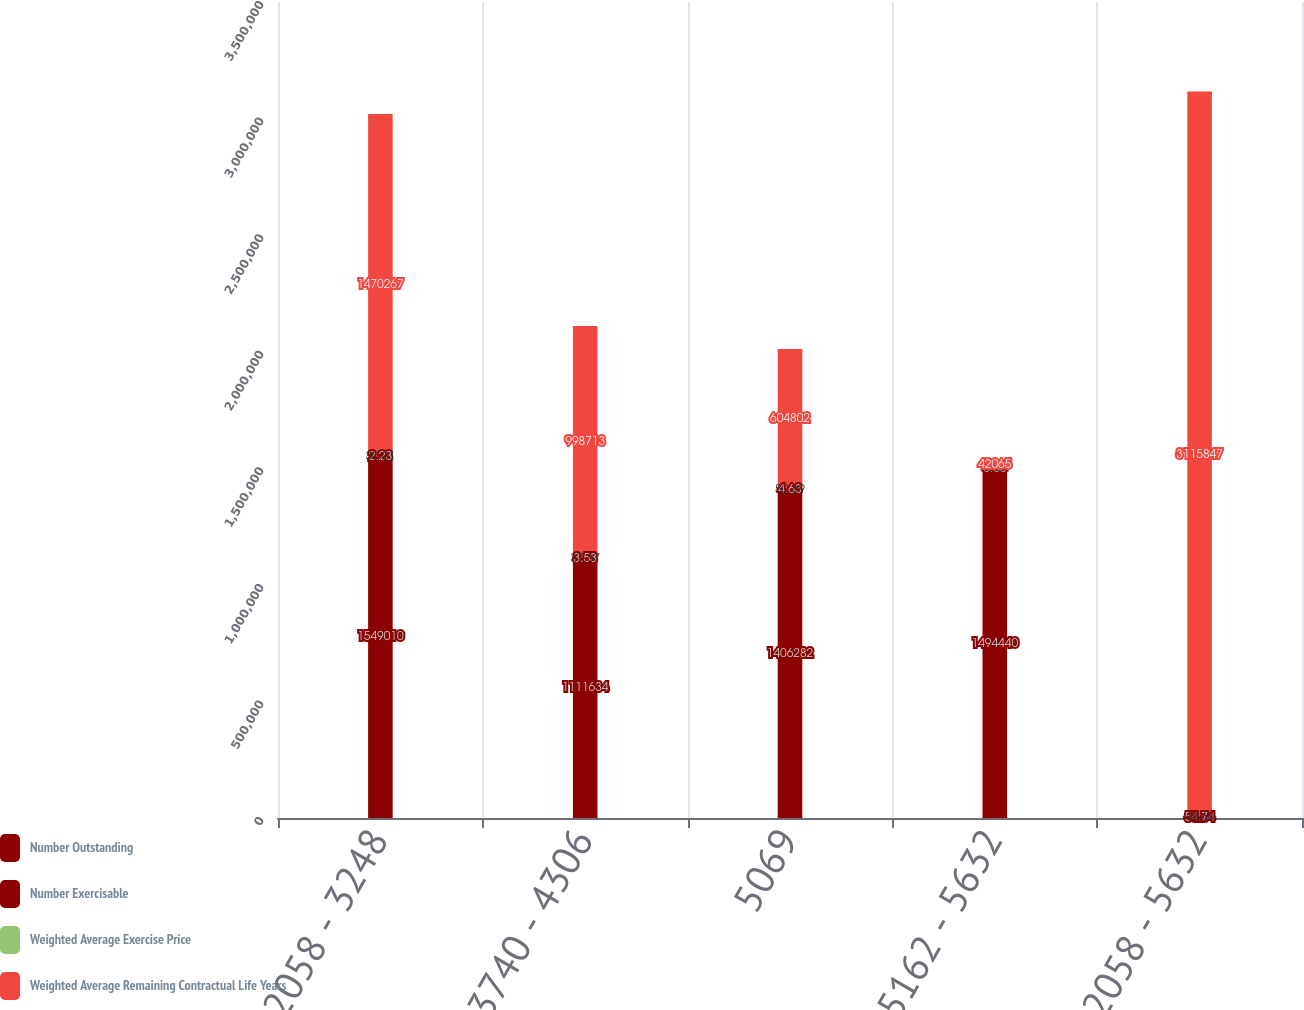<chart> <loc_0><loc_0><loc_500><loc_500><stacked_bar_chart><ecel><fcel>2058 - 3248<fcel>3740 - 4306<fcel>5069<fcel>5162 - 5632<fcel>2058 - 5632<nl><fcel>Number Outstanding<fcel>1.54901e+06<fcel>1.11163e+06<fcel>1.40628e+06<fcel>1.49444e+06<fcel>53.64<nl><fcel>Number Exercisable<fcel>2.23<fcel>3.53<fcel>4.63<fcel>5.65<fcel>4.7<nl><fcel>Weighted Average Exercise Price<fcel>30.01<fcel>37.67<fcel>50.69<fcel>53.64<fcel>44.64<nl><fcel>Weighted Average Remaining Contractual Life Years<fcel>1.47027e+06<fcel>998713<fcel>604802<fcel>42065<fcel>3.11585e+06<nl></chart> 